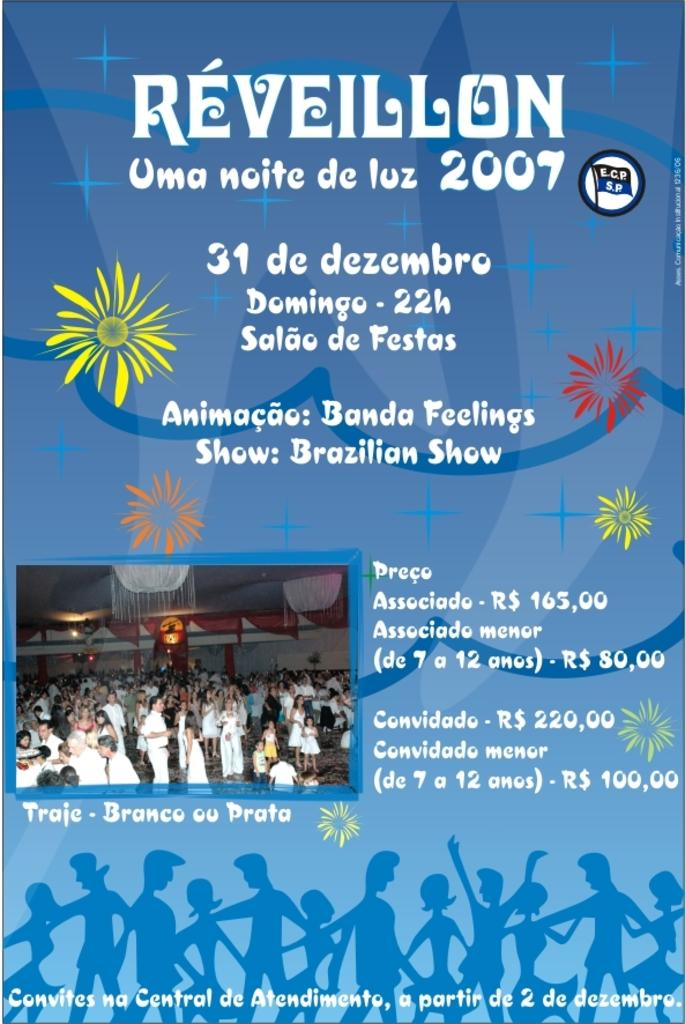<image>
Offer a succinct explanation of the picture presented. The poster shown advertises an event in 2007. 